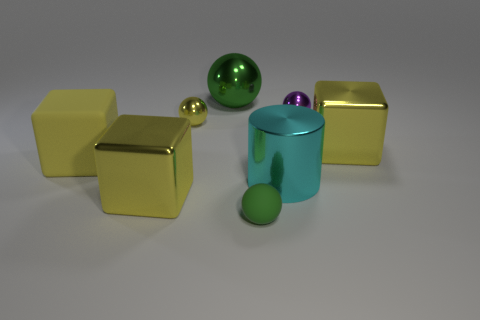There is a yellow metallic block left of the purple shiny object; is it the same size as the small yellow metallic ball? No, it is not the same size. The yellow metallic block to the left of the purple shiny object is significantly larger than the small yellow metallic ball. 